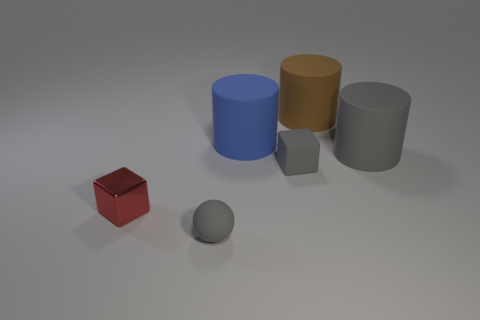Add 3 brown cylinders. How many objects exist? 9 Subtract 2 cylinders. How many cylinders are left? 1 Subtract all cyan spheres. How many cyan cylinders are left? 0 Subtract all brown cylinders. How many cylinders are left? 2 Subtract all cubes. How many objects are left? 4 Subtract all small matte spheres. Subtract all metal objects. How many objects are left? 4 Add 6 big gray matte objects. How many big gray matte objects are left? 7 Add 4 tiny gray cylinders. How many tiny gray cylinders exist? 4 Subtract 1 gray blocks. How many objects are left? 5 Subtract all purple spheres. Subtract all yellow blocks. How many spheres are left? 1 